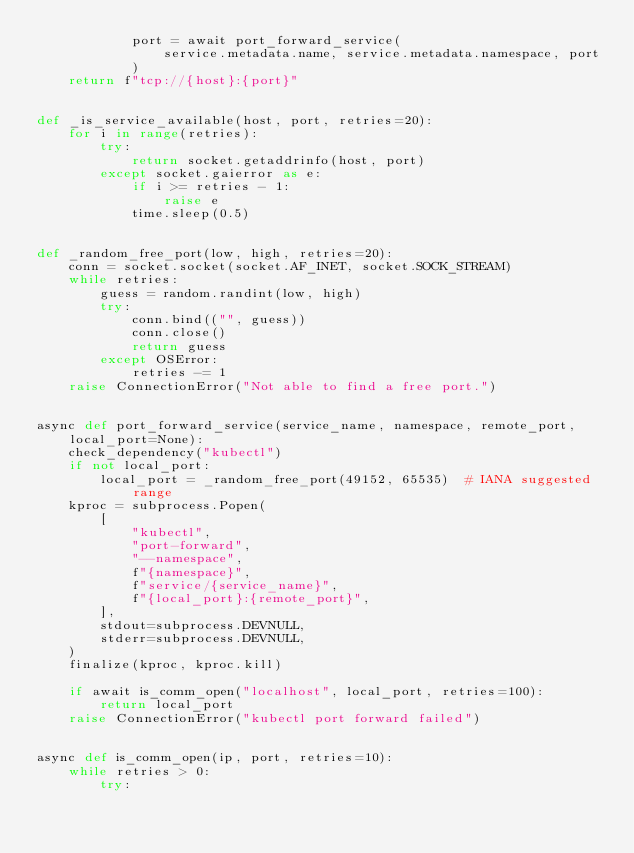<code> <loc_0><loc_0><loc_500><loc_500><_Python_>            port = await port_forward_service(
                service.metadata.name, service.metadata.namespace, port
            )
    return f"tcp://{host}:{port}"


def _is_service_available(host, port, retries=20):
    for i in range(retries):
        try:
            return socket.getaddrinfo(host, port)
        except socket.gaierror as e:
            if i >= retries - 1:
                raise e
            time.sleep(0.5)


def _random_free_port(low, high, retries=20):
    conn = socket.socket(socket.AF_INET, socket.SOCK_STREAM)
    while retries:
        guess = random.randint(low, high)
        try:
            conn.bind(("", guess))
            conn.close()
            return guess
        except OSError:
            retries -= 1
    raise ConnectionError("Not able to find a free port.")


async def port_forward_service(service_name, namespace, remote_port, local_port=None):
    check_dependency("kubectl")
    if not local_port:
        local_port = _random_free_port(49152, 65535)  # IANA suggested range
    kproc = subprocess.Popen(
        [
            "kubectl",
            "port-forward",
            "--namespace",
            f"{namespace}",
            f"service/{service_name}",
            f"{local_port}:{remote_port}",
        ],
        stdout=subprocess.DEVNULL,
        stderr=subprocess.DEVNULL,
    )
    finalize(kproc, kproc.kill)

    if await is_comm_open("localhost", local_port, retries=100):
        return local_port
    raise ConnectionError("kubectl port forward failed")


async def is_comm_open(ip, port, retries=10):
    while retries > 0:
        try:</code> 